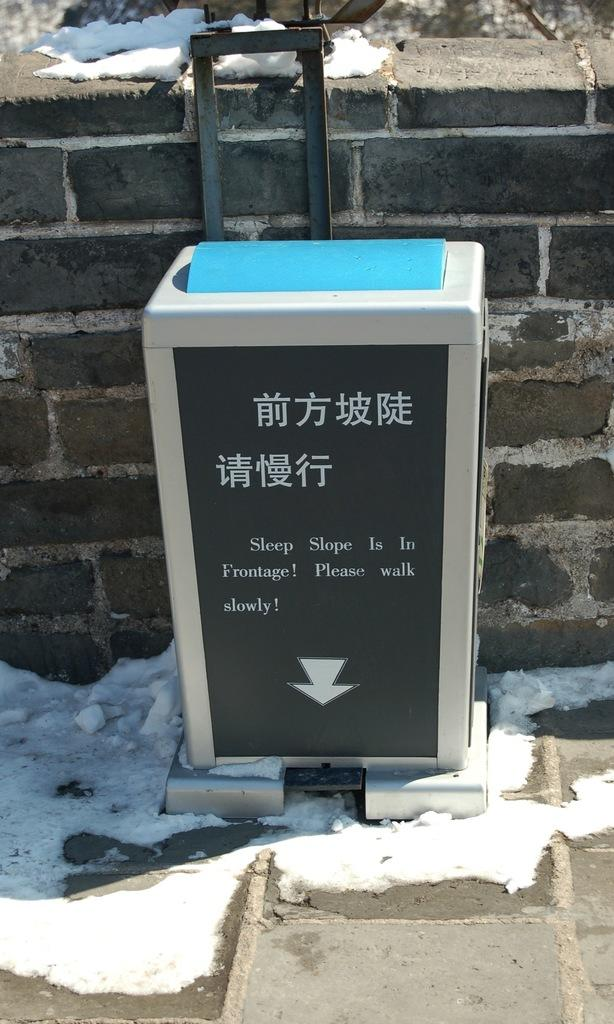<image>
Present a compact description of the photo's key features. Sign outside of a building which says "Sleep slope is in Frontage". 